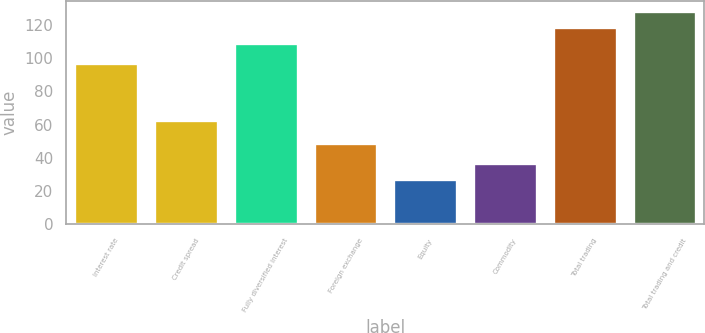Convert chart to OTSL. <chart><loc_0><loc_0><loc_500><loc_500><bar_chart><fcel>Interest rate<fcel>Credit spread<fcel>Fully diversified interest<fcel>Foreign exchange<fcel>Equity<fcel>Commodity<fcel>Total trading<fcel>Total trading and credit<nl><fcel>97<fcel>63<fcel>109<fcel>49<fcel>27<fcel>36.6<fcel>118.6<fcel>128.2<nl></chart> 